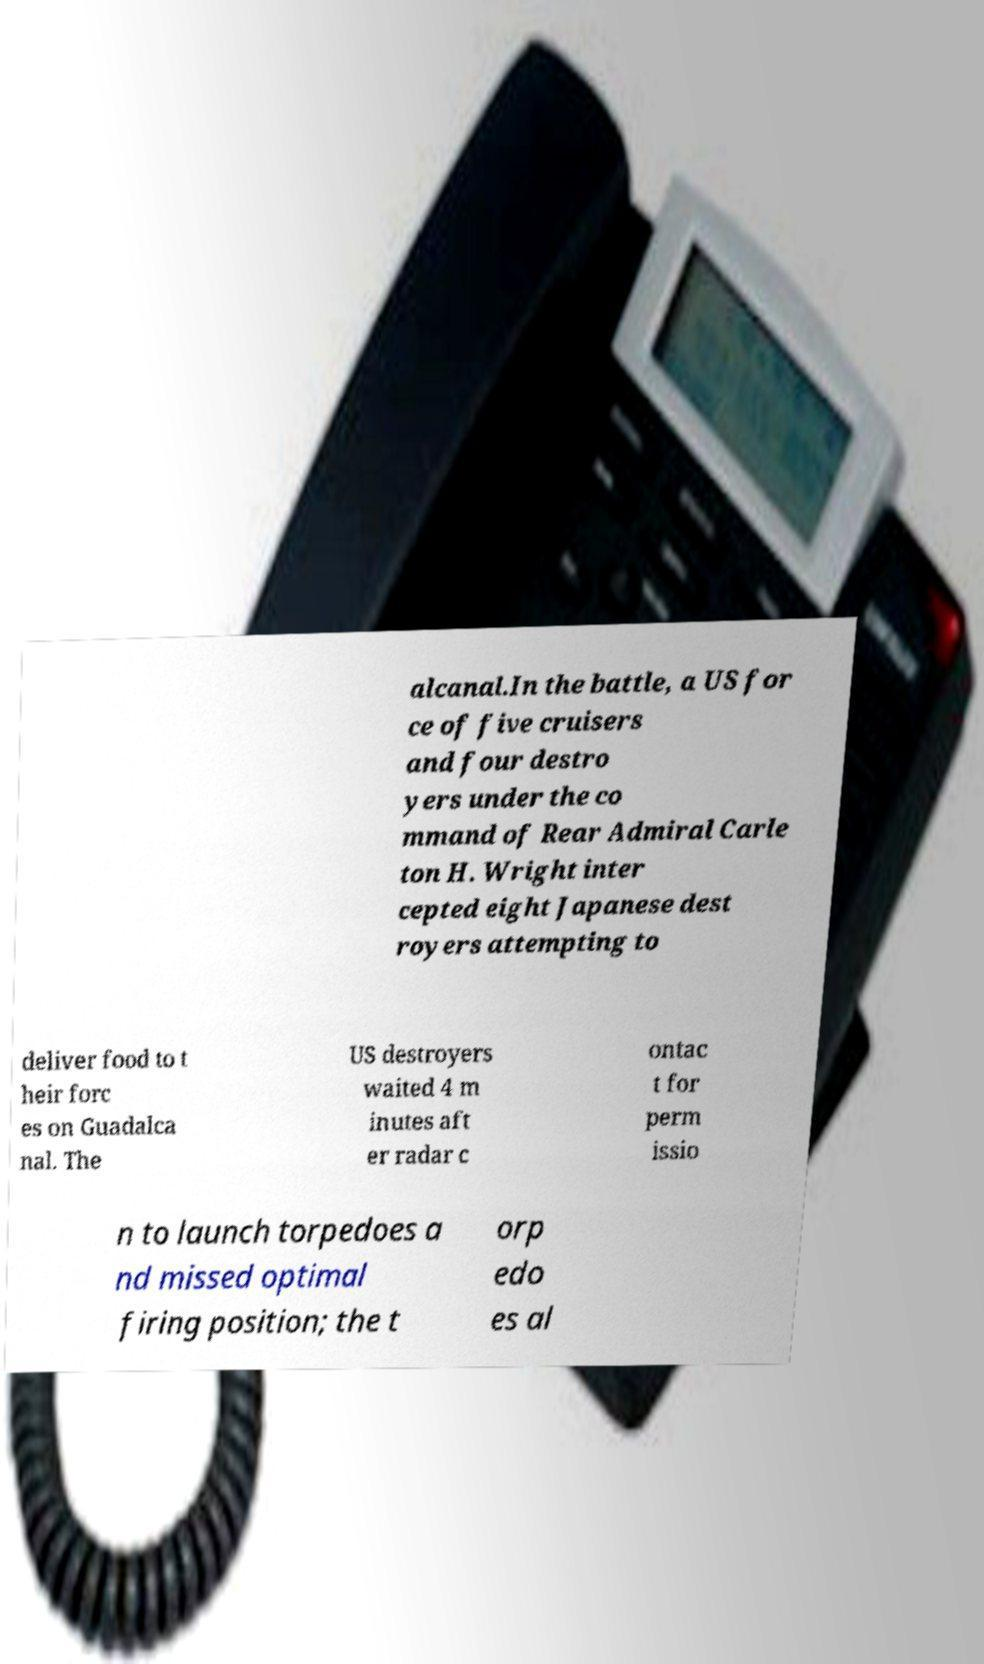What messages or text are displayed in this image? I need them in a readable, typed format. alcanal.In the battle, a US for ce of five cruisers and four destro yers under the co mmand of Rear Admiral Carle ton H. Wright inter cepted eight Japanese dest royers attempting to deliver food to t heir forc es on Guadalca nal. The US destroyers waited 4 m inutes aft er radar c ontac t for perm issio n to launch torpedoes a nd missed optimal firing position; the t orp edo es al 